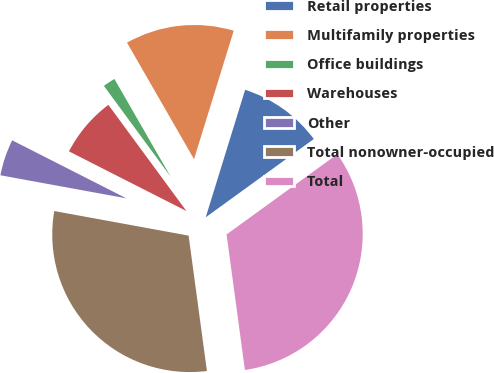<chart> <loc_0><loc_0><loc_500><loc_500><pie_chart><fcel>Retail properties<fcel>Multifamily properties<fcel>Office buildings<fcel>Warehouses<fcel>Other<fcel>Total nonowner-occupied<fcel>Total<nl><fcel>10.25%<fcel>13.08%<fcel>1.78%<fcel>7.43%<fcel>4.6%<fcel>30.02%<fcel>32.84%<nl></chart> 